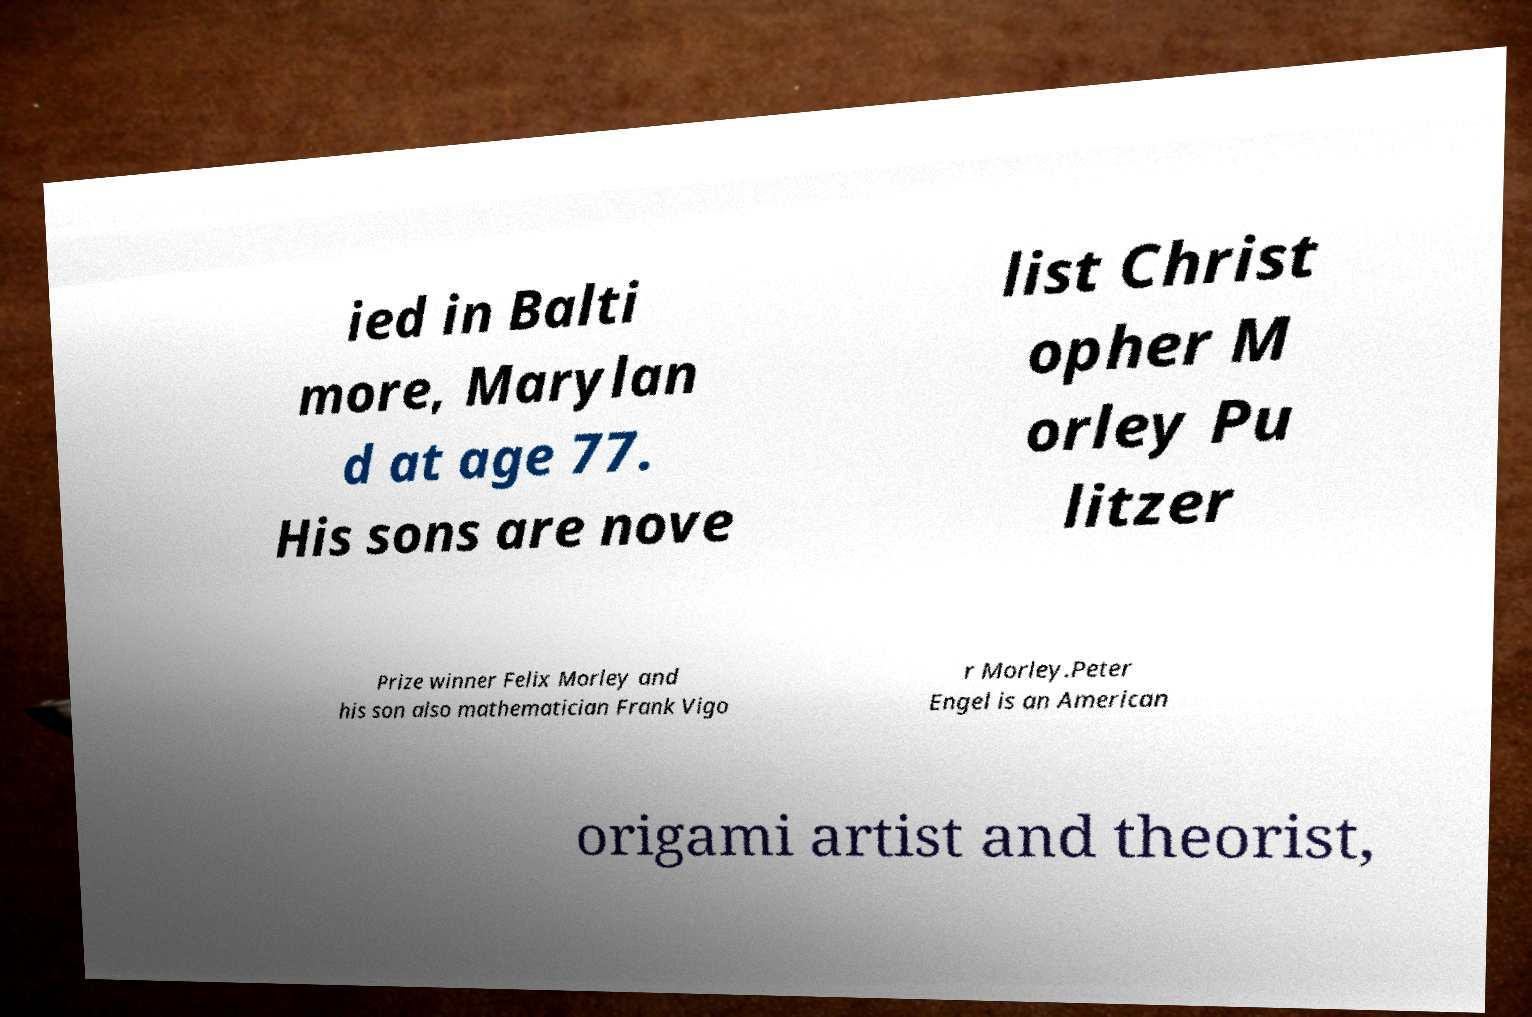Please read and relay the text visible in this image. What does it say? ied in Balti more, Marylan d at age 77. His sons are nove list Christ opher M orley Pu litzer Prize winner Felix Morley and his son also mathematician Frank Vigo r Morley.Peter Engel is an American origami artist and theorist, 